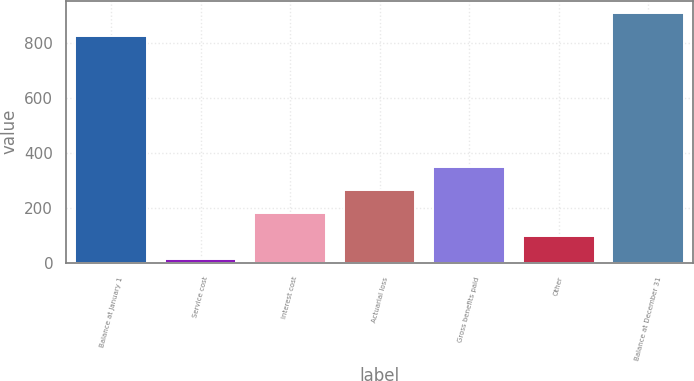Convert chart. <chart><loc_0><loc_0><loc_500><loc_500><bar_chart><fcel>Balance at January 1<fcel>Service cost<fcel>Interest cost<fcel>Actuarial loss<fcel>Gross benefits paid<fcel>Other<fcel>Balance at December 31<nl><fcel>826<fcel>15<fcel>182.6<fcel>266.4<fcel>350.2<fcel>98.8<fcel>909.8<nl></chart> 